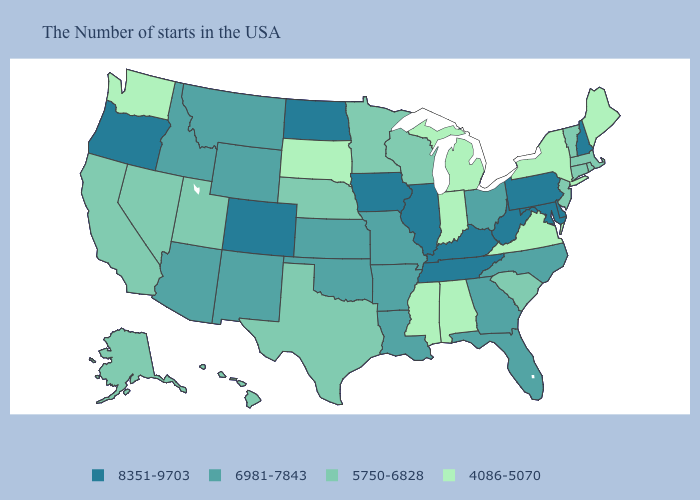Which states have the highest value in the USA?
Short answer required. New Hampshire, Delaware, Maryland, Pennsylvania, West Virginia, Kentucky, Tennessee, Illinois, Iowa, North Dakota, Colorado, Oregon. Name the states that have a value in the range 6981-7843?
Quick response, please. North Carolina, Ohio, Florida, Georgia, Louisiana, Missouri, Arkansas, Kansas, Oklahoma, Wyoming, New Mexico, Montana, Arizona, Idaho. Name the states that have a value in the range 8351-9703?
Concise answer only. New Hampshire, Delaware, Maryland, Pennsylvania, West Virginia, Kentucky, Tennessee, Illinois, Iowa, North Dakota, Colorado, Oregon. What is the highest value in the USA?
Answer briefly. 8351-9703. Name the states that have a value in the range 4086-5070?
Quick response, please. Maine, New York, Virginia, Michigan, Indiana, Alabama, Mississippi, South Dakota, Washington. What is the value of Maryland?
Answer briefly. 8351-9703. What is the value of West Virginia?
Concise answer only. 8351-9703. What is the value of Illinois?
Concise answer only. 8351-9703. What is the highest value in the USA?
Write a very short answer. 8351-9703. What is the value of Washington?
Give a very brief answer. 4086-5070. Name the states that have a value in the range 8351-9703?
Concise answer only. New Hampshire, Delaware, Maryland, Pennsylvania, West Virginia, Kentucky, Tennessee, Illinois, Iowa, North Dakota, Colorado, Oregon. Name the states that have a value in the range 8351-9703?
Short answer required. New Hampshire, Delaware, Maryland, Pennsylvania, West Virginia, Kentucky, Tennessee, Illinois, Iowa, North Dakota, Colorado, Oregon. Does Alaska have the lowest value in the USA?
Concise answer only. No. What is the lowest value in the USA?
Give a very brief answer. 4086-5070. Does Iowa have the highest value in the USA?
Short answer required. Yes. 